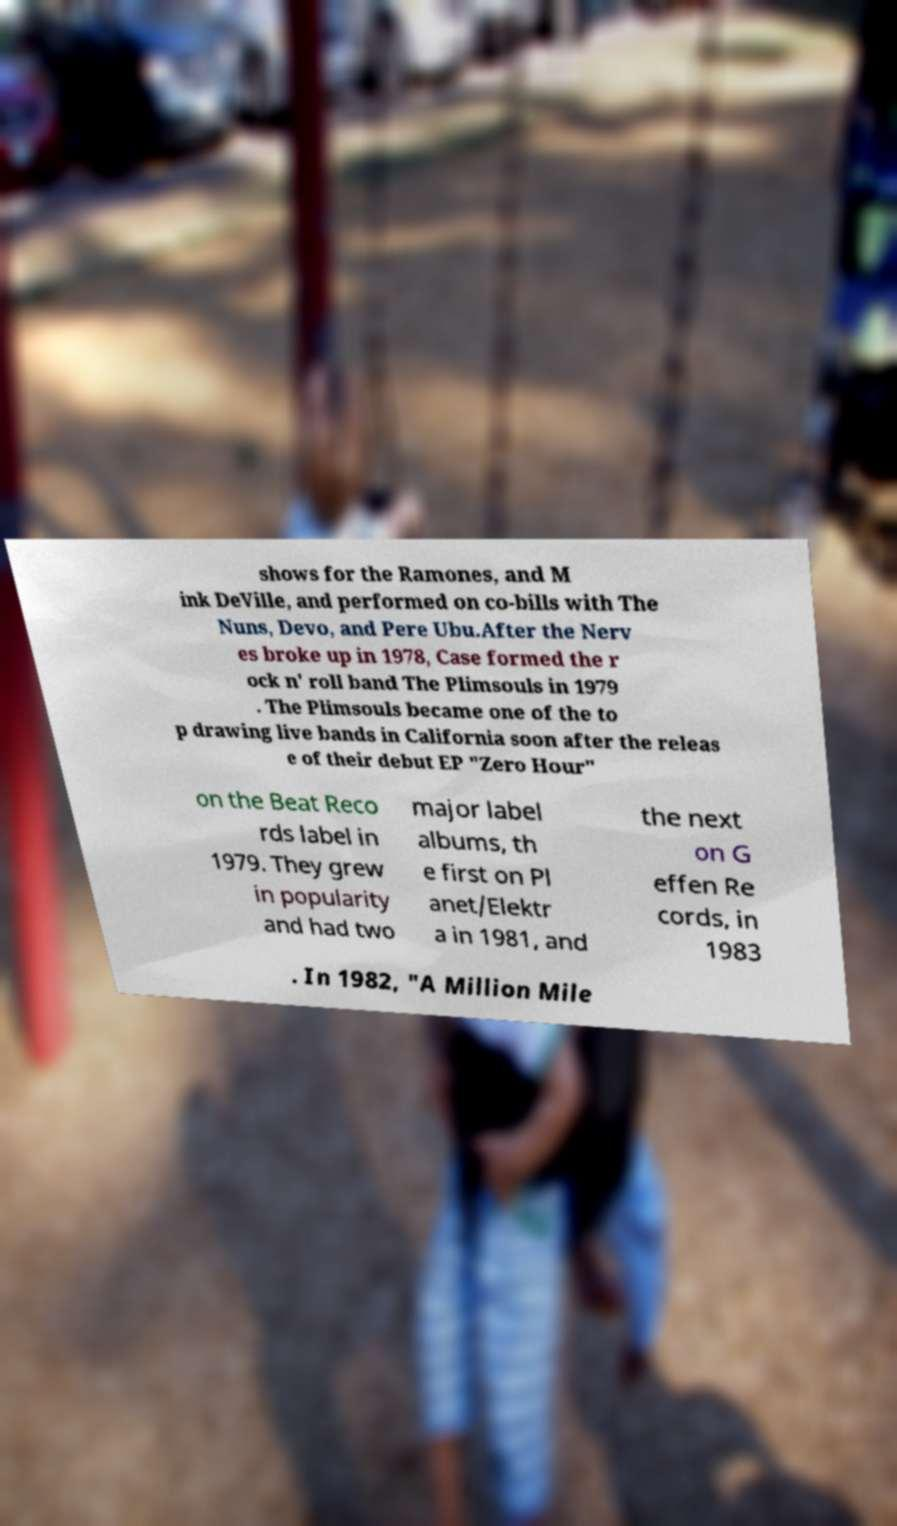Can you accurately transcribe the text from the provided image for me? shows for the Ramones, and M ink DeVille, and performed on co-bills with The Nuns, Devo, and Pere Ubu.After the Nerv es broke up in 1978, Case formed the r ock n' roll band The Plimsouls in 1979 . The Plimsouls became one of the to p drawing live bands in California soon after the releas e of their debut EP "Zero Hour" on the Beat Reco rds label in 1979. They grew in popularity and had two major label albums, th e first on Pl anet/Elektr a in 1981, and the next on G effen Re cords, in 1983 . In 1982, "A Million Mile 